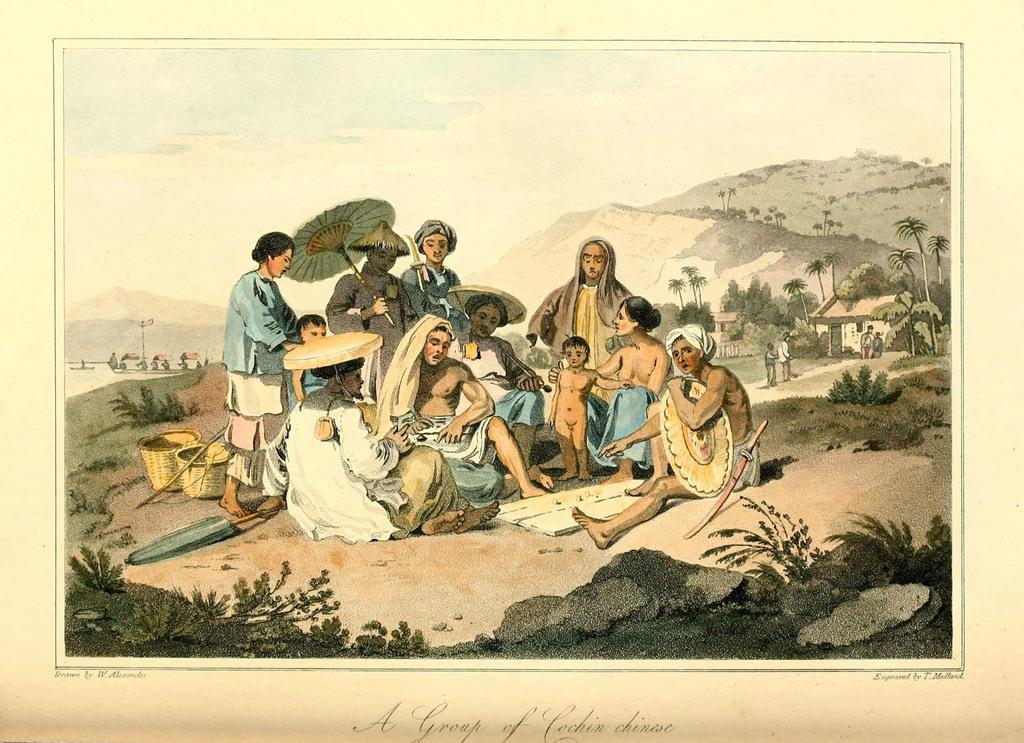What type of visual representation is the image? The image is a poster. What can be seen in the group of people in the image? There is a group of people in the image. What objects are present in the image? There are baskets in the image. What type of structures are visible in the image? There are houses in the image. What type of natural elements can be seen in the image? There are trees in the image. What is visible in the background of the image? The sky is visible in the background of the image. How many times does the visitor smile in the image? There is no visitor present in the image, so it is not possible to determine how many times they smile. 